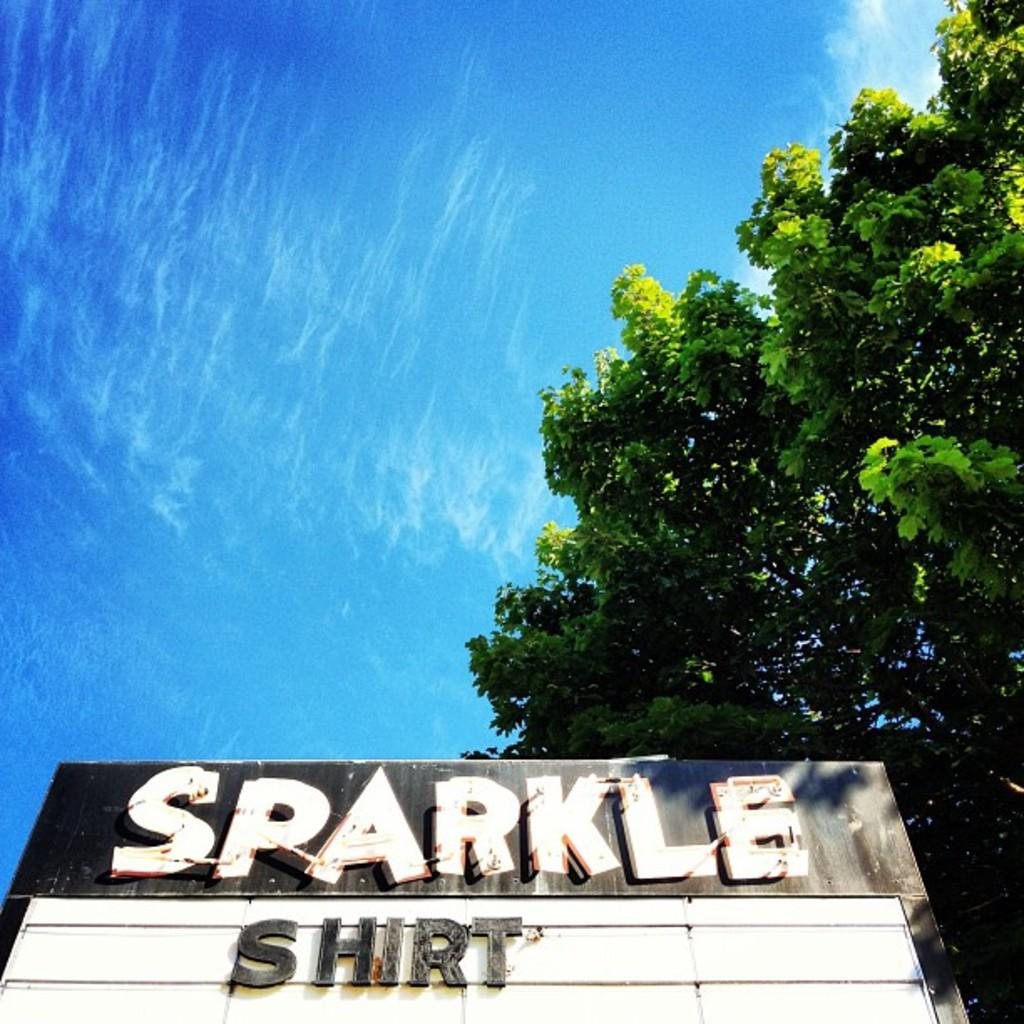What is the main object in the image? There is a board in the image. What is the color scheme of the board? The board is in black and white color. What can be seen in the background of the image? There are trees and the sky visible in the background of the image. What is the color of the trees in the image? The trees are in green color. What is the color of the sky in the image? The sky is in blue and white color. How many passengers are on the toy boat in the image? There is no toy boat or passengers present in the image. What type of river can be seen in the image? There is no river present in the image. 